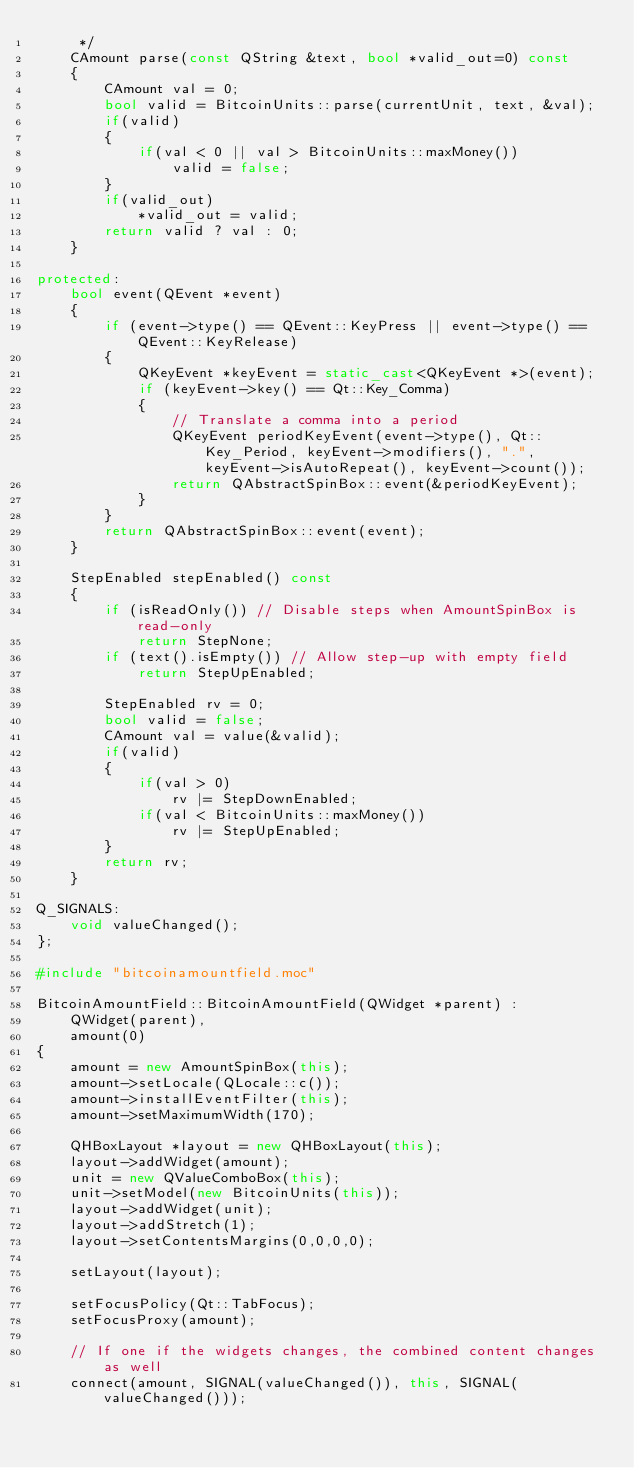<code> <loc_0><loc_0><loc_500><loc_500><_C++_>     */
    CAmount parse(const QString &text, bool *valid_out=0) const
    {
        CAmount val = 0;
        bool valid = BitcoinUnits::parse(currentUnit, text, &val);
        if(valid)
        {
            if(val < 0 || val > BitcoinUnits::maxMoney())
                valid = false;
        }
        if(valid_out)
            *valid_out = valid;
        return valid ? val : 0;
    }

protected:
    bool event(QEvent *event)
    {
        if (event->type() == QEvent::KeyPress || event->type() == QEvent::KeyRelease)
        {
            QKeyEvent *keyEvent = static_cast<QKeyEvent *>(event);
            if (keyEvent->key() == Qt::Key_Comma)
            {
                // Translate a comma into a period
                QKeyEvent periodKeyEvent(event->type(), Qt::Key_Period, keyEvent->modifiers(), ".", keyEvent->isAutoRepeat(), keyEvent->count());
                return QAbstractSpinBox::event(&periodKeyEvent);
            }
        }
        return QAbstractSpinBox::event(event);
    }

    StepEnabled stepEnabled() const
    {
        if (isReadOnly()) // Disable steps when AmountSpinBox is read-only
            return StepNone;
        if (text().isEmpty()) // Allow step-up with empty field
            return StepUpEnabled;

        StepEnabled rv = 0;
        bool valid = false;
        CAmount val = value(&valid);
        if(valid)
        {
            if(val > 0)
                rv |= StepDownEnabled;
            if(val < BitcoinUnits::maxMoney())
                rv |= StepUpEnabled;
        }
        return rv;
    }

Q_SIGNALS:
    void valueChanged();
};

#include "bitcoinamountfield.moc"

BitcoinAmountField::BitcoinAmountField(QWidget *parent) :
    QWidget(parent),
    amount(0)
{
    amount = new AmountSpinBox(this);
    amount->setLocale(QLocale::c());
    amount->installEventFilter(this);
    amount->setMaximumWidth(170);

    QHBoxLayout *layout = new QHBoxLayout(this);
    layout->addWidget(amount);
    unit = new QValueComboBox(this);
    unit->setModel(new BitcoinUnits(this));
    layout->addWidget(unit);
    layout->addStretch(1);
    layout->setContentsMargins(0,0,0,0);

    setLayout(layout);

    setFocusPolicy(Qt::TabFocus);
    setFocusProxy(amount);

    // If one if the widgets changes, the combined content changes as well
    connect(amount, SIGNAL(valueChanged()), this, SIGNAL(valueChanged()));</code> 